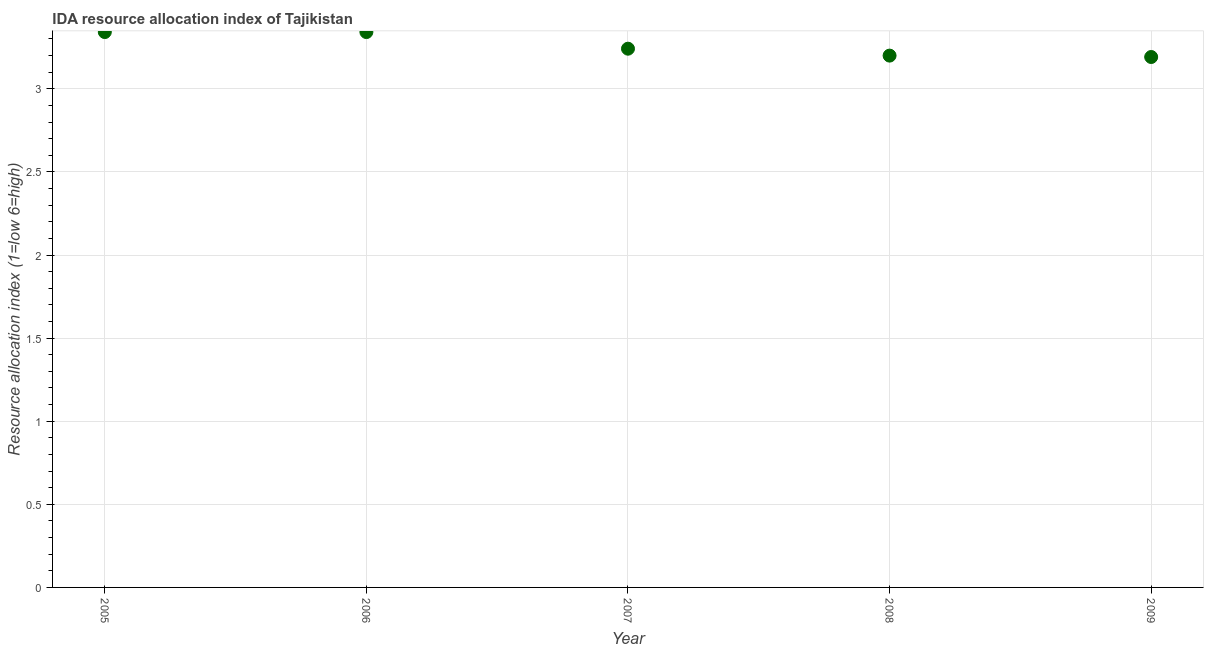What is the ida resource allocation index in 2006?
Give a very brief answer. 3.34. Across all years, what is the maximum ida resource allocation index?
Make the answer very short. 3.34. Across all years, what is the minimum ida resource allocation index?
Keep it short and to the point. 3.19. In which year was the ida resource allocation index minimum?
Offer a terse response. 2009. What is the sum of the ida resource allocation index?
Provide a succinct answer. 16.32. What is the difference between the ida resource allocation index in 2008 and 2009?
Ensure brevity in your answer.  0.01. What is the average ida resource allocation index per year?
Provide a short and direct response. 3.26. What is the median ida resource allocation index?
Your answer should be compact. 3.24. What is the ratio of the ida resource allocation index in 2005 to that in 2009?
Provide a short and direct response. 1.05. Is the ida resource allocation index in 2006 less than that in 2008?
Give a very brief answer. No. Is the sum of the ida resource allocation index in 2005 and 2009 greater than the maximum ida resource allocation index across all years?
Your response must be concise. Yes. What is the difference between the highest and the lowest ida resource allocation index?
Ensure brevity in your answer.  0.15. Does the ida resource allocation index monotonically increase over the years?
Keep it short and to the point. No. How many dotlines are there?
Ensure brevity in your answer.  1. Does the graph contain grids?
Your answer should be very brief. Yes. What is the title of the graph?
Your response must be concise. IDA resource allocation index of Tajikistan. What is the label or title of the X-axis?
Keep it short and to the point. Year. What is the label or title of the Y-axis?
Your answer should be very brief. Resource allocation index (1=low 6=high). What is the Resource allocation index (1=low 6=high) in 2005?
Give a very brief answer. 3.34. What is the Resource allocation index (1=low 6=high) in 2006?
Make the answer very short. 3.34. What is the Resource allocation index (1=low 6=high) in 2007?
Your response must be concise. 3.24. What is the Resource allocation index (1=low 6=high) in 2009?
Give a very brief answer. 3.19. What is the difference between the Resource allocation index (1=low 6=high) in 2005 and 2006?
Your response must be concise. 0. What is the difference between the Resource allocation index (1=low 6=high) in 2005 and 2007?
Your answer should be very brief. 0.1. What is the difference between the Resource allocation index (1=low 6=high) in 2005 and 2008?
Provide a short and direct response. 0.14. What is the difference between the Resource allocation index (1=low 6=high) in 2006 and 2007?
Offer a very short reply. 0.1. What is the difference between the Resource allocation index (1=low 6=high) in 2006 and 2008?
Make the answer very short. 0.14. What is the difference between the Resource allocation index (1=low 6=high) in 2007 and 2008?
Give a very brief answer. 0.04. What is the difference between the Resource allocation index (1=low 6=high) in 2008 and 2009?
Offer a very short reply. 0.01. What is the ratio of the Resource allocation index (1=low 6=high) in 2005 to that in 2007?
Offer a very short reply. 1.03. What is the ratio of the Resource allocation index (1=low 6=high) in 2005 to that in 2008?
Your answer should be compact. 1.04. What is the ratio of the Resource allocation index (1=low 6=high) in 2005 to that in 2009?
Provide a succinct answer. 1.05. What is the ratio of the Resource allocation index (1=low 6=high) in 2006 to that in 2007?
Give a very brief answer. 1.03. What is the ratio of the Resource allocation index (1=low 6=high) in 2006 to that in 2008?
Ensure brevity in your answer.  1.04. What is the ratio of the Resource allocation index (1=low 6=high) in 2006 to that in 2009?
Give a very brief answer. 1.05. 